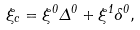Convert formula to latex. <formula><loc_0><loc_0><loc_500><loc_500>\xi _ { c } = \xi ^ { 0 } \Delta ^ { 0 } + \xi ^ { 1 } \delta ^ { 0 } ,</formula> 